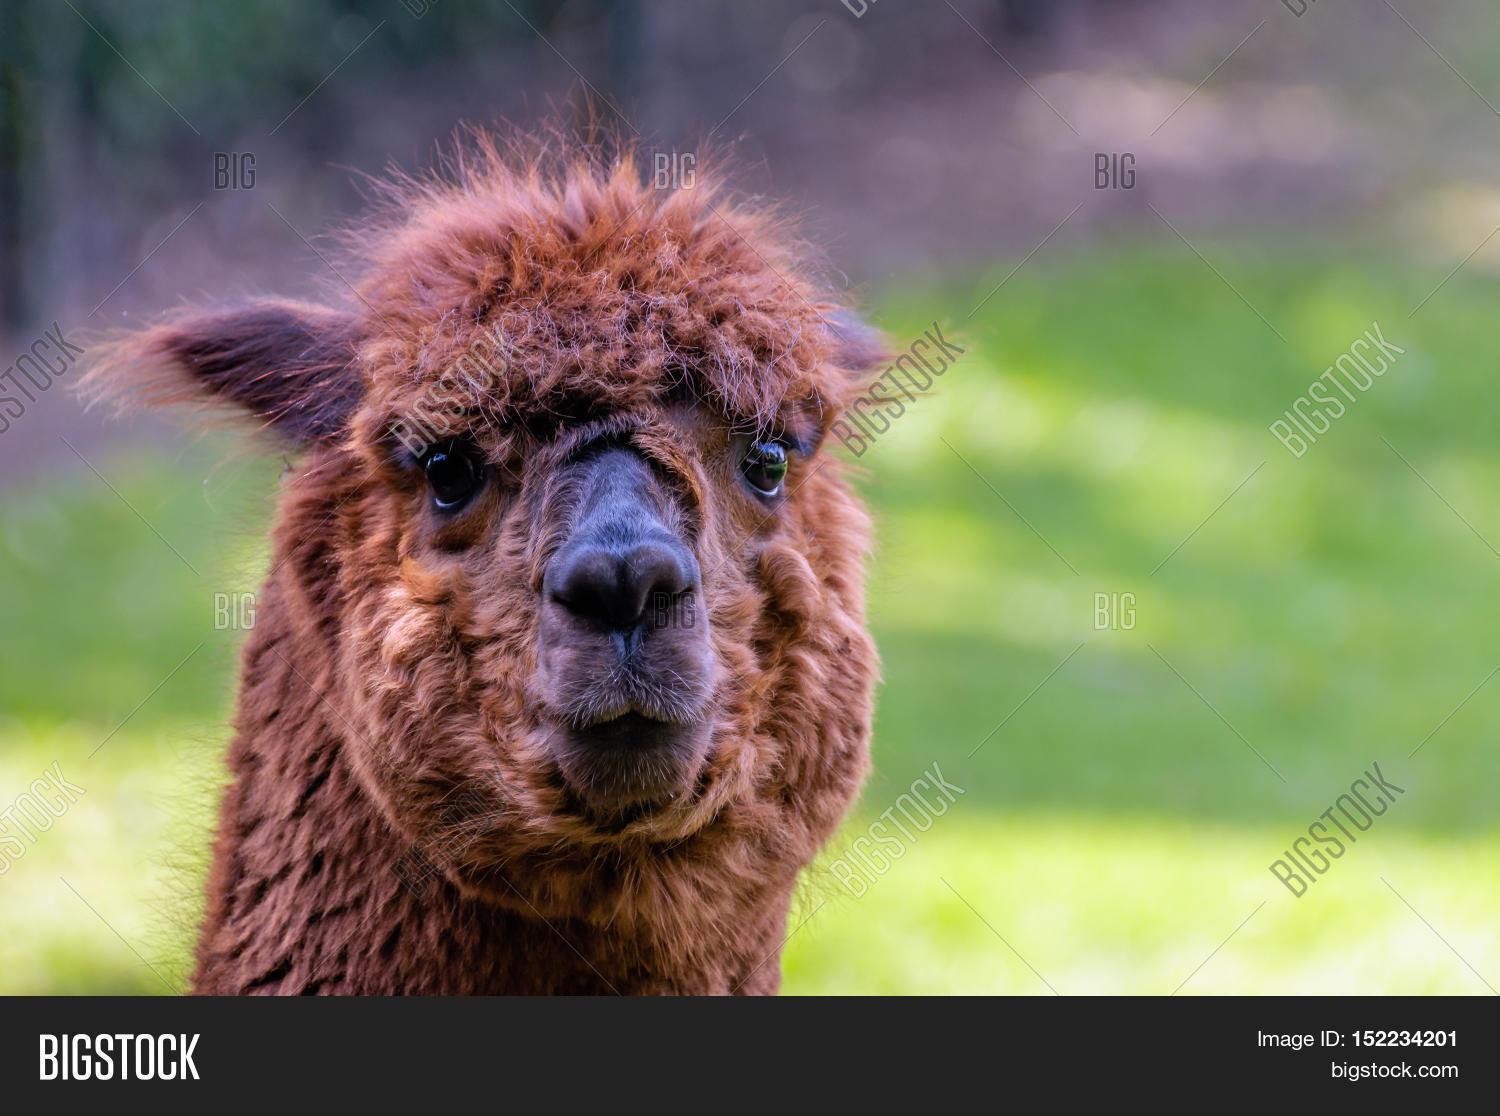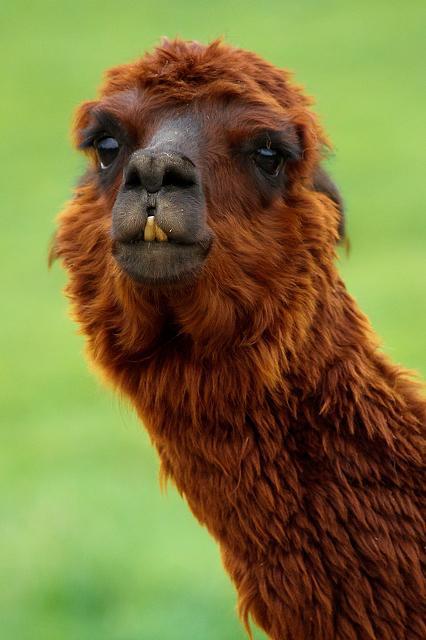The first image is the image on the left, the second image is the image on the right. For the images shown, is this caption "The head of one llama can seen in each image and none of them have brown fur." true? Answer yes or no. No. The first image is the image on the left, the second image is the image on the right. Given the left and right images, does the statement "Four llama eyes are visible." hold true? Answer yes or no. Yes. 